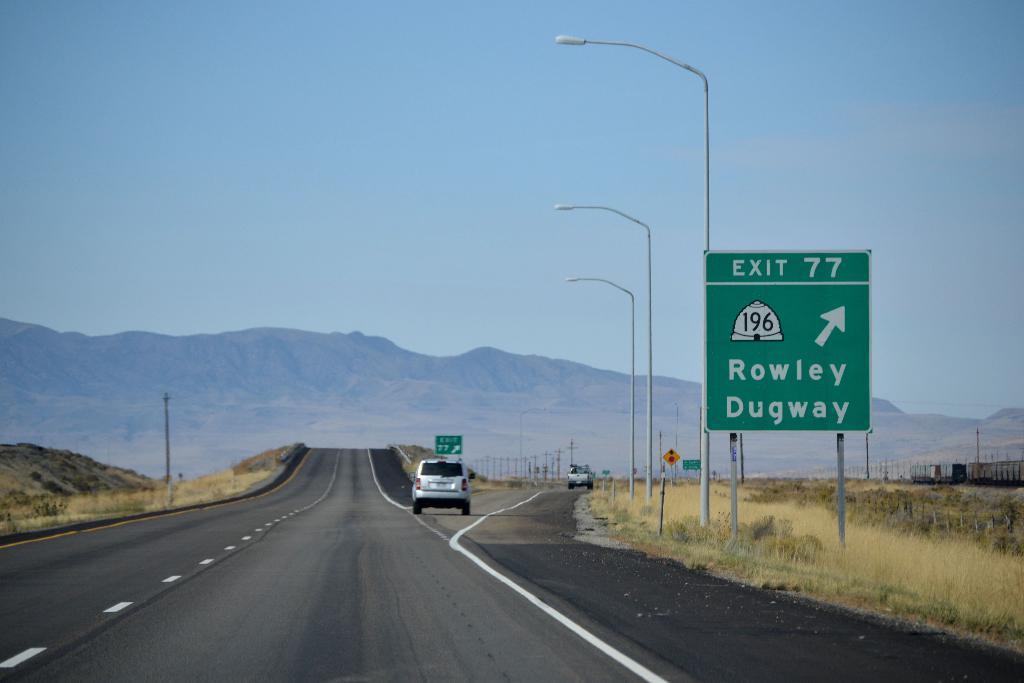Is there a rest area off exit 77?
Offer a terse response. Unanswerable. 